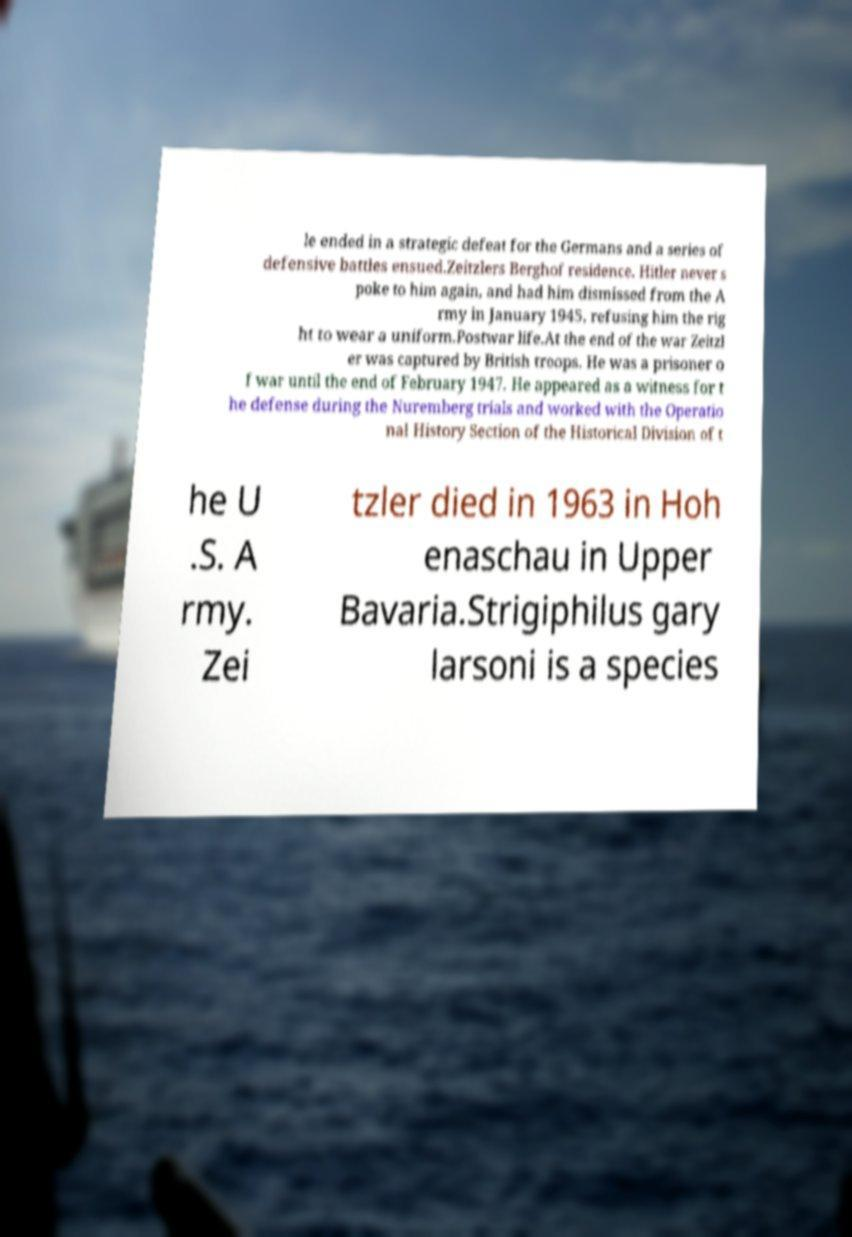Can you read and provide the text displayed in the image?This photo seems to have some interesting text. Can you extract and type it out for me? le ended in a strategic defeat for the Germans and a series of defensive battles ensued.Zeitzlers Berghof residence. Hitler never s poke to him again, and had him dismissed from the A rmy in January 1945, refusing him the rig ht to wear a uniform.Postwar life.At the end of the war Zeitzl er was captured by British troops. He was a prisoner o f war until the end of February 1947. He appeared as a witness for t he defense during the Nuremberg trials and worked with the Operatio nal History Section of the Historical Division of t he U .S. A rmy. Zei tzler died in 1963 in Hoh enaschau in Upper Bavaria.Strigiphilus gary larsoni is a species 